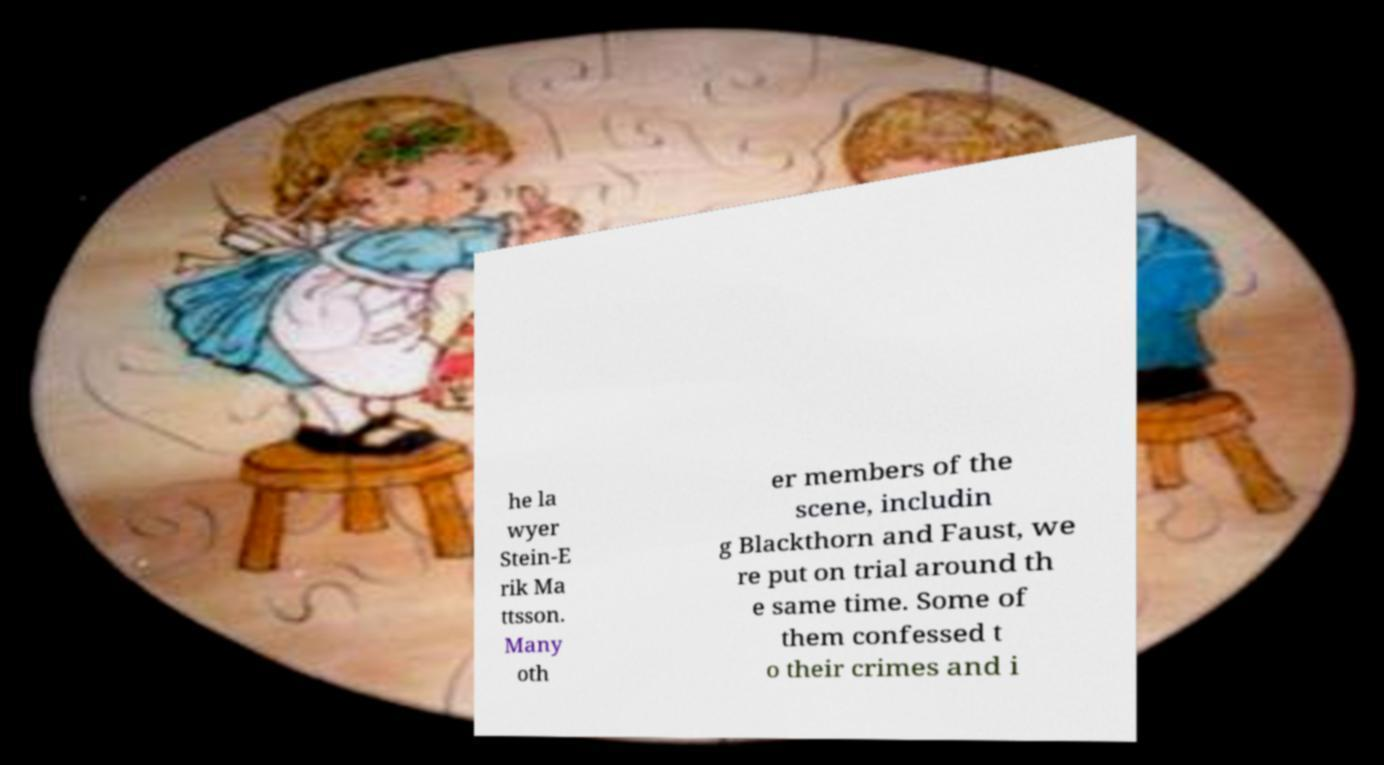For documentation purposes, I need the text within this image transcribed. Could you provide that? he la wyer Stein-E rik Ma ttsson. Many oth er members of the scene, includin g Blackthorn and Faust, we re put on trial around th e same time. Some of them confessed t o their crimes and i 